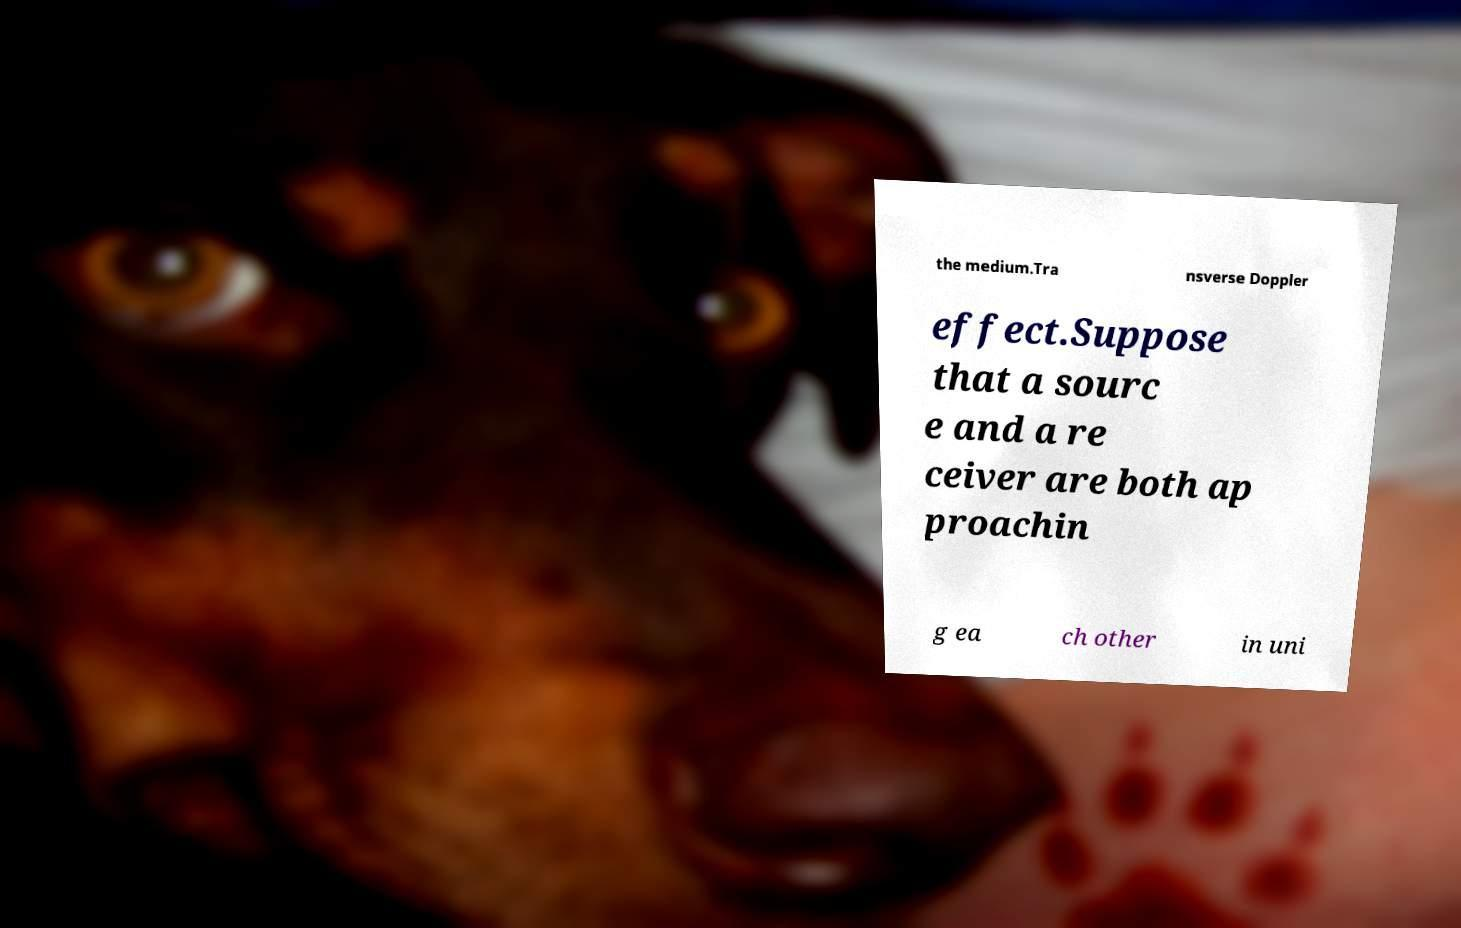Please read and relay the text visible in this image. What does it say? the medium.Tra nsverse Doppler effect.Suppose that a sourc e and a re ceiver are both ap proachin g ea ch other in uni 